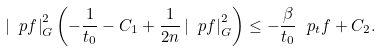Convert formula to latex. <formula><loc_0><loc_0><loc_500><loc_500>\left | \ p f \right | ^ { 2 } _ { G } \left ( - \frac { 1 } { t _ { 0 } } - C _ { 1 } + \frac { 1 } { 2 n } \left | \ p f \right | ^ { 2 } _ { G } \right ) \leq - \frac { \beta } { t _ { 0 } } \ p _ { t } f + C _ { 2 } .</formula> 